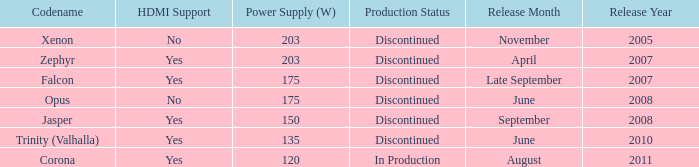Does Trinity (valhalla) have HDMI? Yes. 